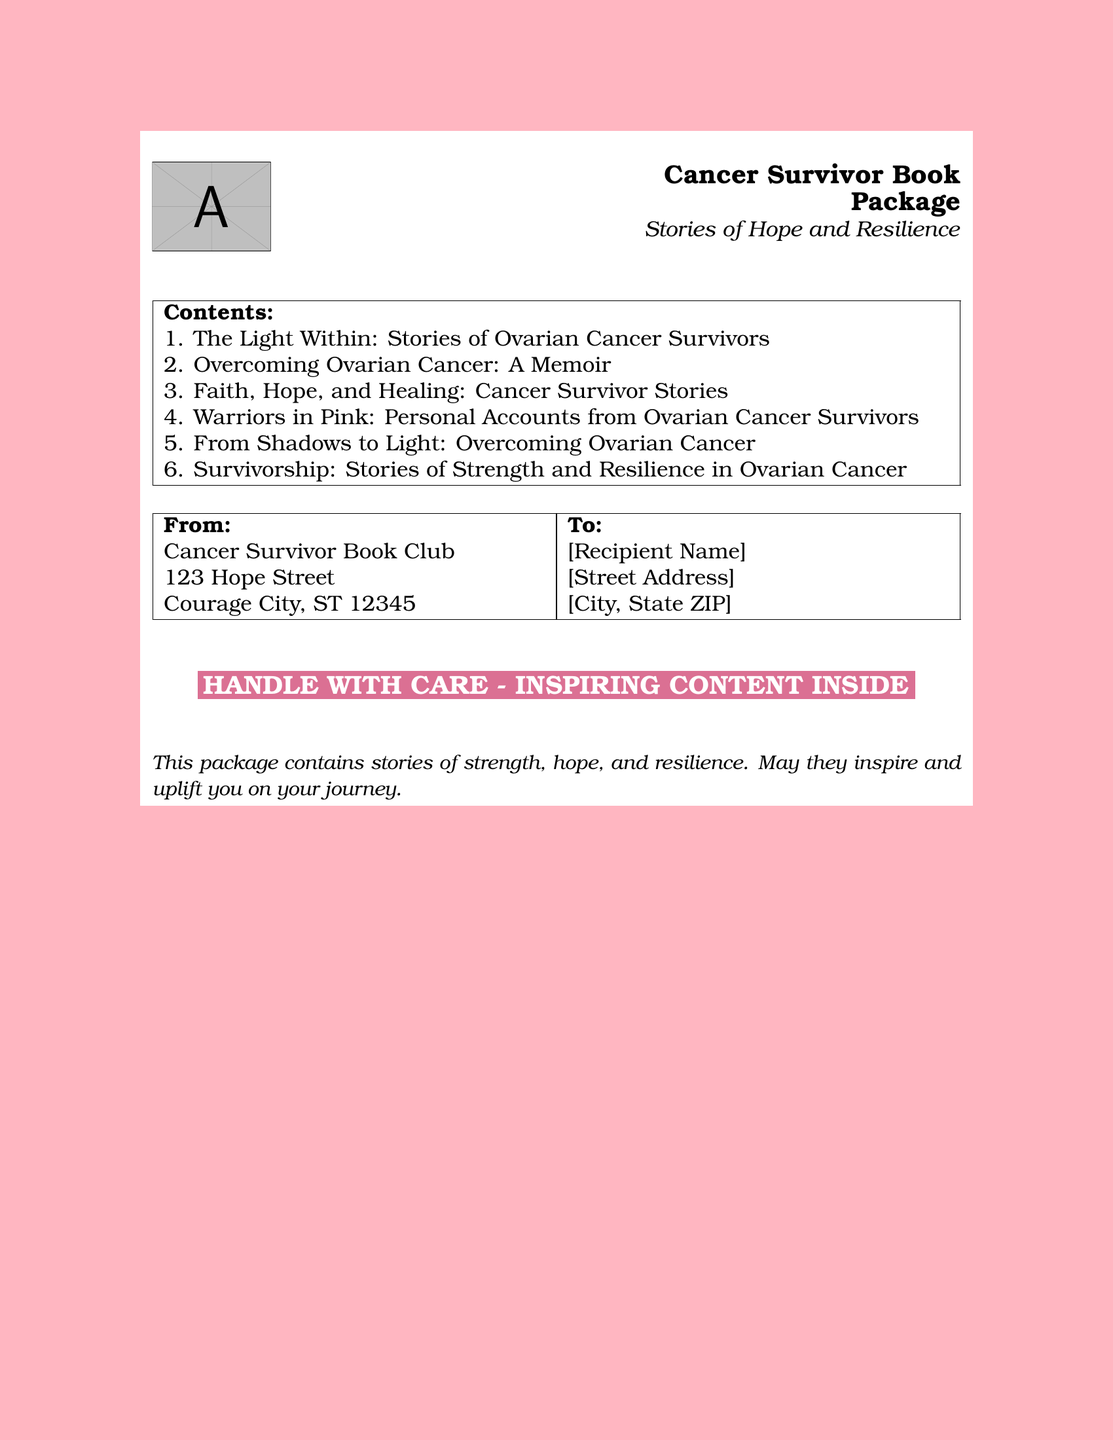What is the title of the first book? The document lists the contents of the package, starting with the first title which is “The Light Within: Stories of Ovarian Cancer Survivors.”
Answer: The Light Within: Stories of Ovarian Cancer Survivors How many books are in the package? The document enumerates the books contained, tallying up to six titles.
Answer: 6 What is the address of the sender? The document specifies the sender's address as "123 Hope Street, Courage City, ST 12345."
Answer: 123 Hope Street, Courage City, ST 12345 What kind of stories does the package contain? The document states that the package includes "stories of strength, hope, and resilience."
Answer: strength, hope, and resilience Who is the sender of the package? The sender is identified as "Cancer Survivor Book Club" in the document.
Answer: Cancer Survivor Book Club What color is the background of the shipping label? The document specifies a light pink background for the label.
Answer: light pink What is the message inside the package? The document includes an uplifting message stating the purpose of the package’s contents: "This package contains stories of strength, hope, and resilience."
Answer: stories of strength, hope, and resilience What should be done with the package? The document features a notice that says "HANDLE WITH CARE - INSPIRING CONTENT INSIDE."
Answer: HANDLE WITH CARE - INSPIRING CONTENT INSIDE What is the theme of the package? The document highlights "Stories of Hope and Resilience" as the overarching theme of the book package.
Answer: Stories of Hope and Resilience 